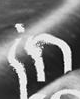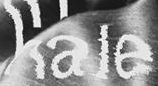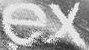Identify the words shown in these images in order, separated by a semicolon. in; hale; ex 